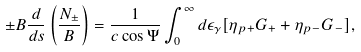Convert formula to latex. <formula><loc_0><loc_0><loc_500><loc_500>\pm B \frac { d } { d s } \left ( \frac { N _ { \pm } } { B } \right ) = \frac { 1 } { c \cos \Psi } \int _ { 0 } ^ { \infty } d \epsilon _ { \gamma } [ \eta _ { p + } G _ { + } + \eta _ { p - } G _ { - } ] ,</formula> 